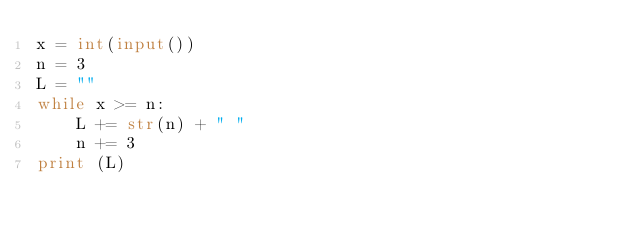Convert code to text. <code><loc_0><loc_0><loc_500><loc_500><_Python_>x = int(input())
n = 3
L = ""
while x >= n:
    L += str(n) + " "
    n += 3
print (L)</code> 